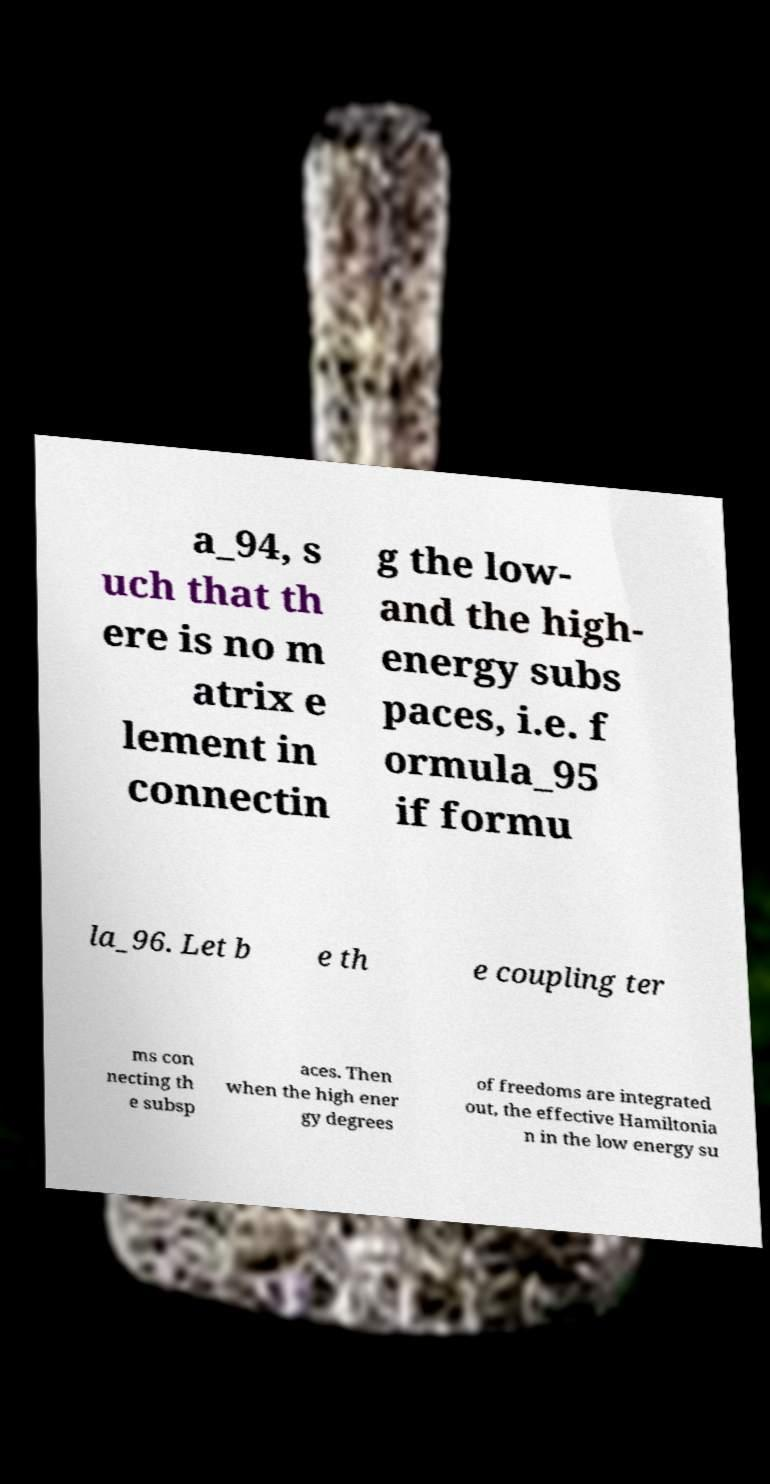Please identify and transcribe the text found in this image. a_94, s uch that th ere is no m atrix e lement in connectin g the low- and the high- energy subs paces, i.e. f ormula_95 if formu la_96. Let b e th e coupling ter ms con necting th e subsp aces. Then when the high ener gy degrees of freedoms are integrated out, the effective Hamiltonia n in the low energy su 